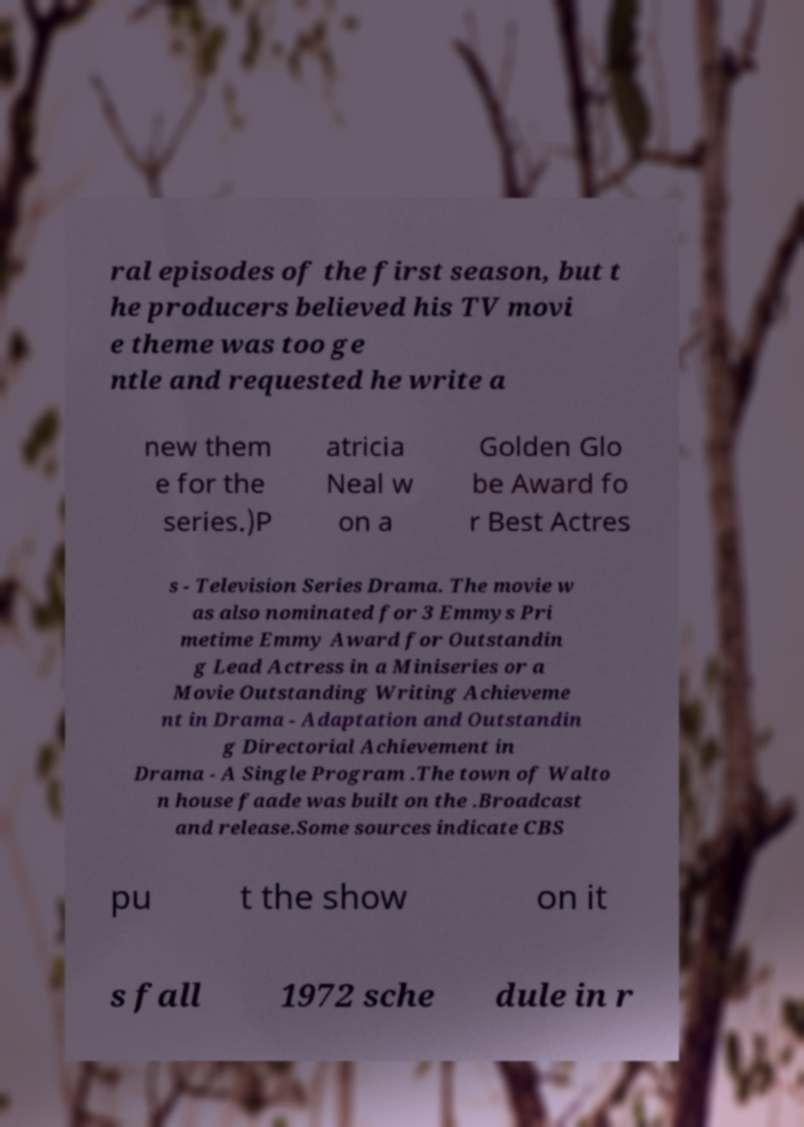Could you extract and type out the text from this image? ral episodes of the first season, but t he producers believed his TV movi e theme was too ge ntle and requested he write a new them e for the series.)P atricia Neal w on a Golden Glo be Award fo r Best Actres s - Television Series Drama. The movie w as also nominated for 3 Emmys Pri metime Emmy Award for Outstandin g Lead Actress in a Miniseries or a Movie Outstanding Writing Achieveme nt in Drama - Adaptation and Outstandin g Directorial Achievement in Drama - A Single Program .The town of Walto n house faade was built on the .Broadcast and release.Some sources indicate CBS pu t the show on it s fall 1972 sche dule in r 